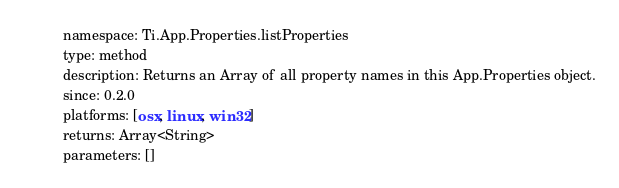<code> <loc_0><loc_0><loc_500><loc_500><_YAML_>namespace: Ti.App.Properties.listProperties
type: method
description: Returns an Array of all property names in this App.Properties object.
since: 0.2.0
platforms: [osx, linux, win32]
returns: Array<String>
parameters: []
</code> 